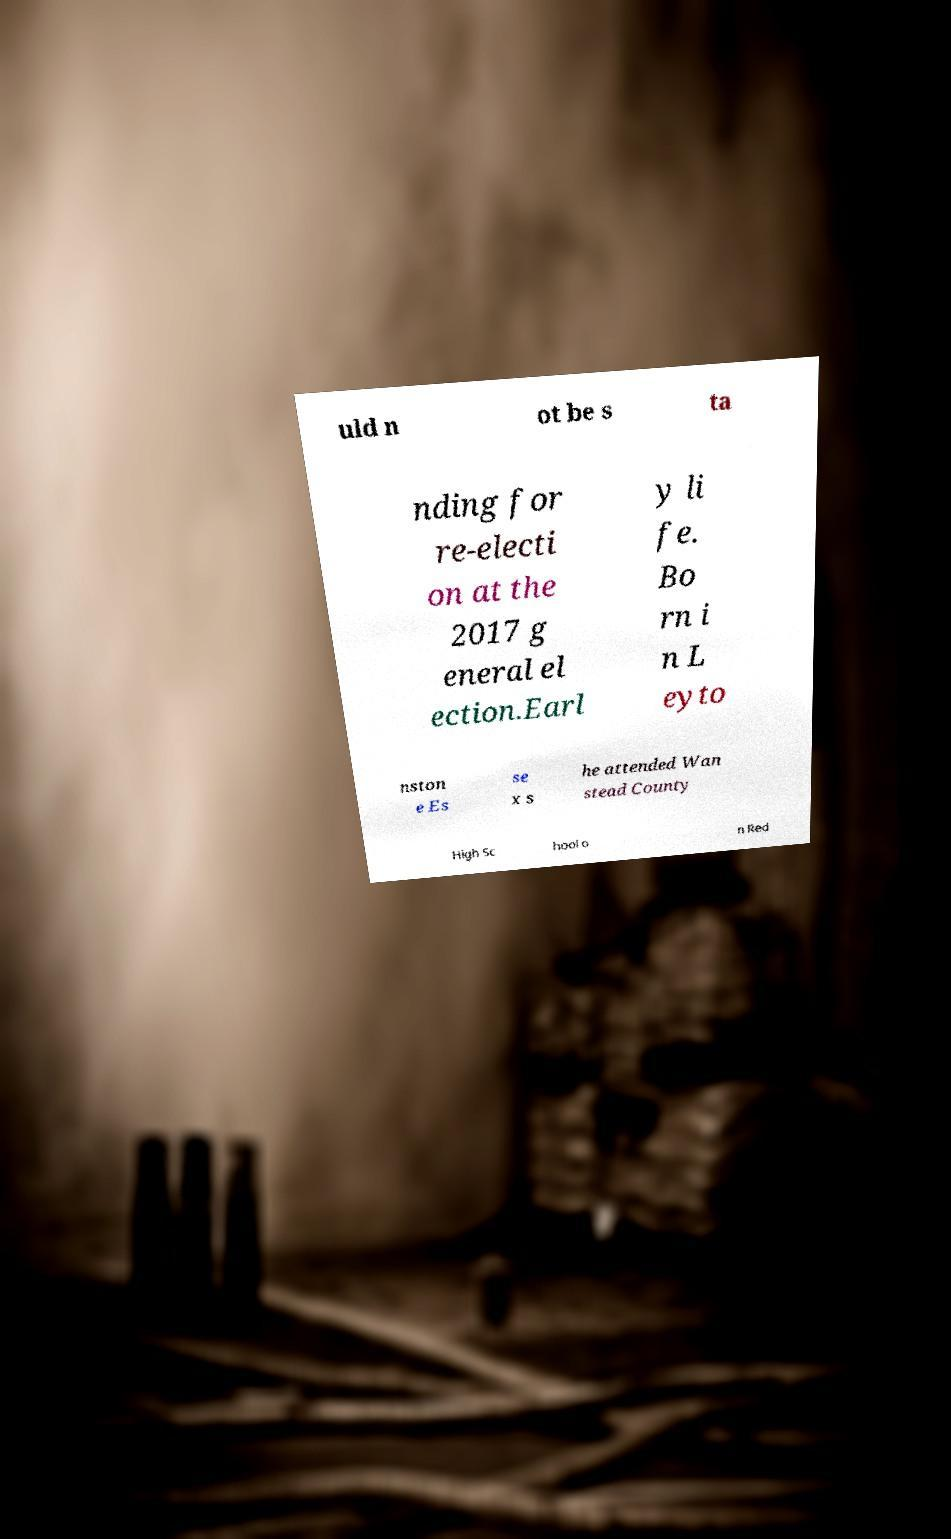What messages or text are displayed in this image? I need them in a readable, typed format. uld n ot be s ta nding for re-electi on at the 2017 g eneral el ection.Earl y li fe. Bo rn i n L eyto nston e Es se x s he attended Wan stead County High Sc hool o n Red 